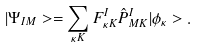<formula> <loc_0><loc_0><loc_500><loc_500>| \Psi _ { I M } > = \sum _ { \kappa K } F ^ { I } _ { \kappa K } \hat { P } ^ { I } _ { M K } | \phi _ { \kappa } > .</formula> 